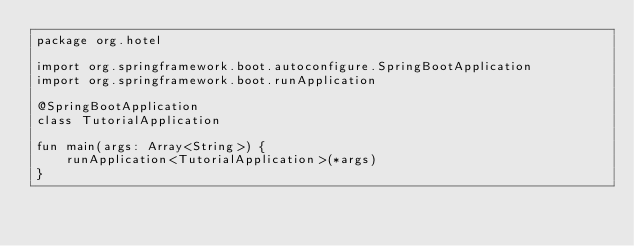<code> <loc_0><loc_0><loc_500><loc_500><_Kotlin_>package org.hotel

import org.springframework.boot.autoconfigure.SpringBootApplication
import org.springframework.boot.runApplication

@SpringBootApplication
class TutorialApplication

fun main(args: Array<String>) {
	runApplication<TutorialApplication>(*args)
}
</code> 